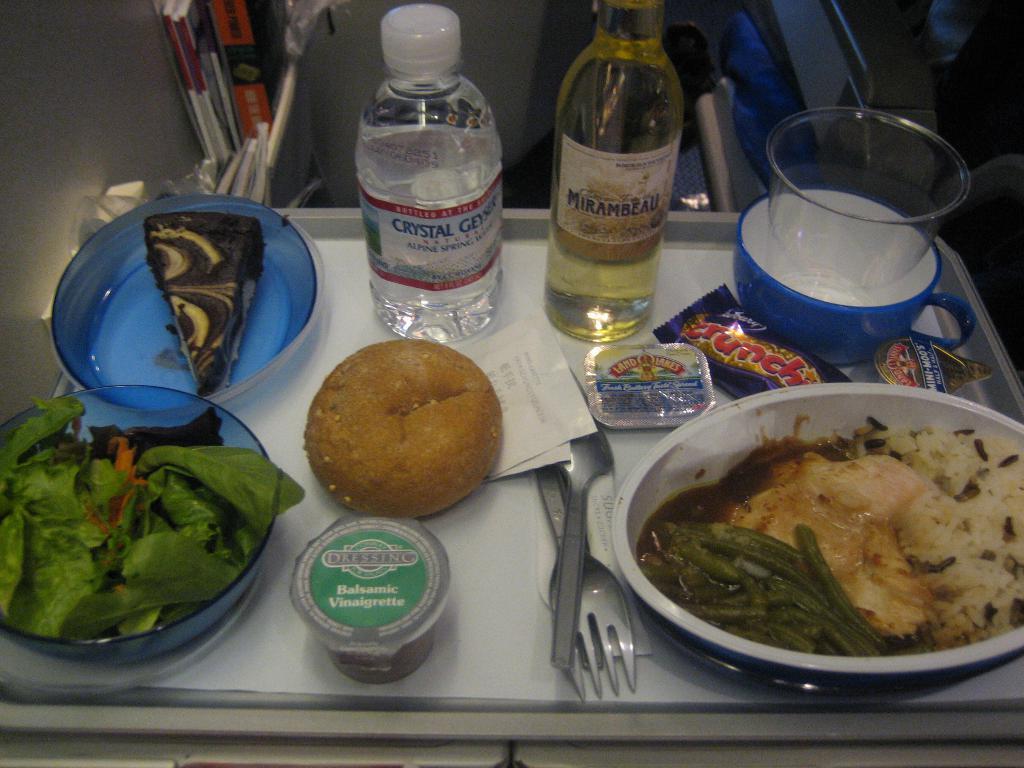Please provide a concise description of this image. In the image in the center, we can see one plate. In the plate, we can see bowls, spoons, pepper packets, one bill paper, bottles, one bun, some food items and a few other objects. In the background we can see books etc. 